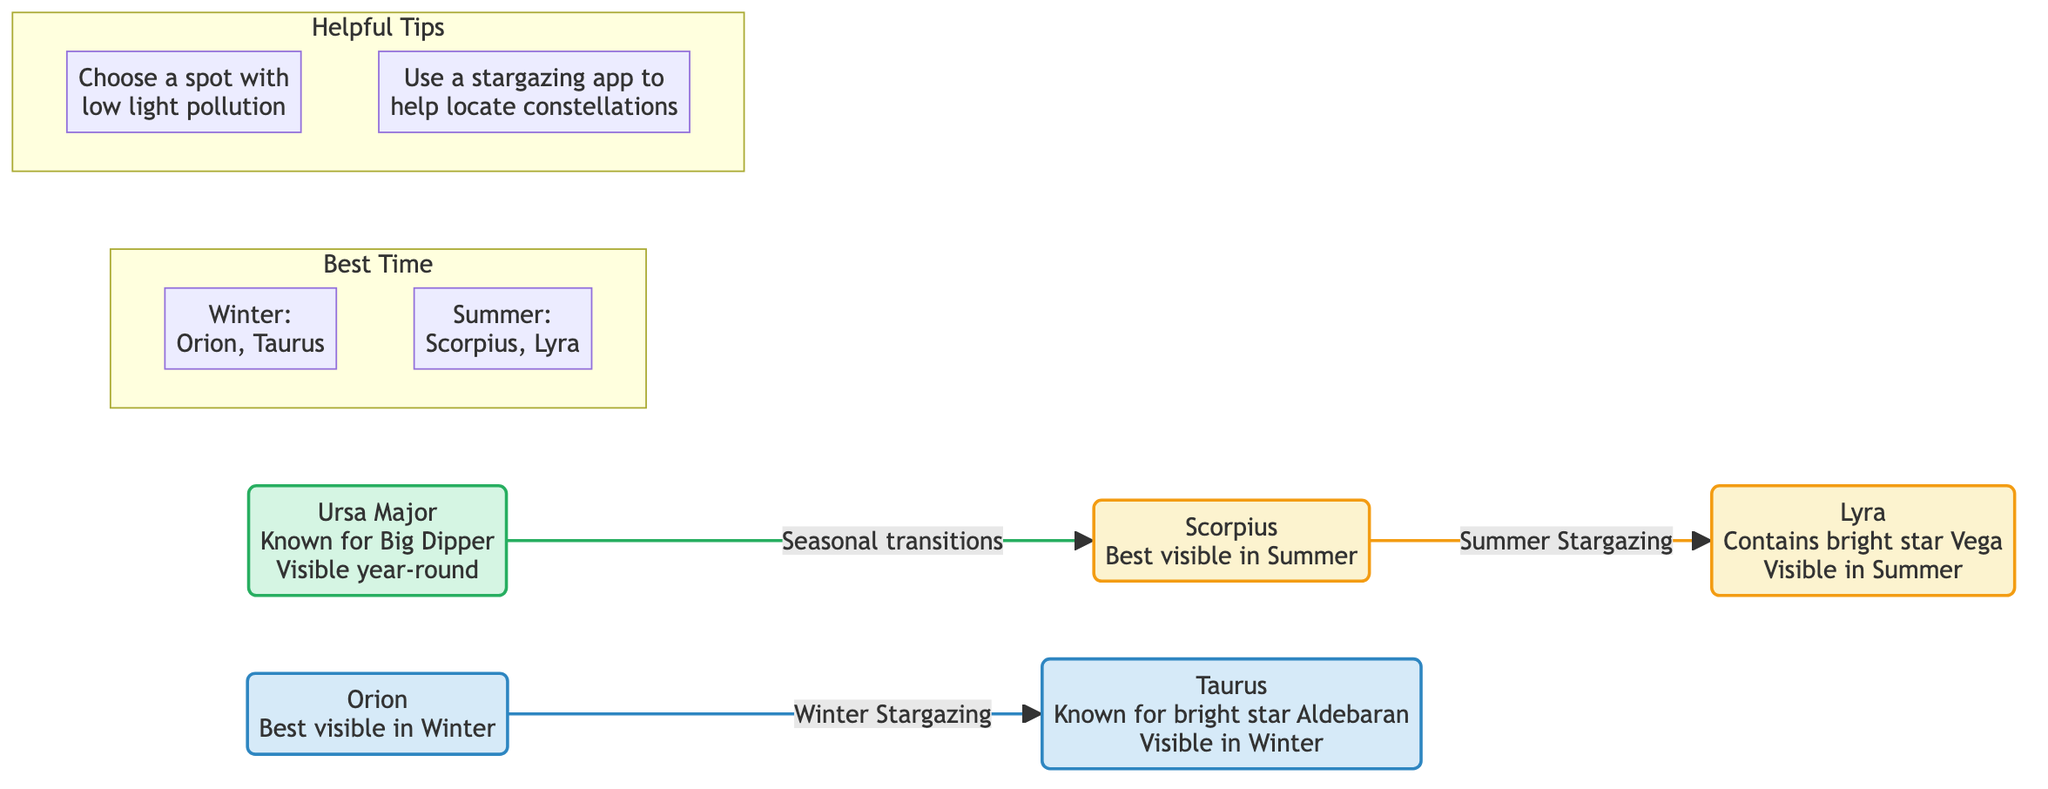What is the best time to view Orion? The diagram indicates Orion is best visible in Winter, as stated next to the Orion node.
Answer: Winter How many constellations are listed in the diagram? Counting the nodes in the diagram, there are five: Orion, Ursa Major, Scorpius, Lyra, and Taurus.
Answer: Five Which constellation is known for the Big Dipper? The diagram notes that Ursa Major is known for the Big Dipper, as mentioned directly in its node description.
Answer: Ursa Major What is the relationship between Ursa Major and Scorpius? The diagram shows a connection labeled "Seasonal transitions," indicating a relationship between Ursa Major and Scorpius.
Answer: Seasonal transitions Which constellation contains the bright star Vega? According to the diagram, the Lyra constellation contains the bright star Vega, as stated in its description.
Answer: Lyra What are two tips provided for stargazing? The diagram includes two tips: "Choose a spot with low light pollution" and "Use a stargazing app to help locate constellations."
Answer: Choose a spot with low light pollution; Use a stargazing app How many constellations are visible year-round? The diagram shows that Ursa Major is the only constellation labeled as visible year-round, which means there is one.
Answer: One Which constellations can be viewed in Summer? The diagram indicates that Scorpius and Lyra are visible in Summer as noted in their respective nodes.
Answer: Scorpius, Lyra What color represents the winter constellations in the diagram? The winter constellations, Orion and Taurus, are represented in blue, as shown by the color assigned to the winterNode class.
Answer: Blue What is the connection between Scorpius and Lyra? The diagram indicates that Scorpius is connected to Lyra through a relationship labeled "Summer Stargazing."
Answer: Summer Stargazing 